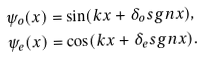Convert formula to latex. <formula><loc_0><loc_0><loc_500><loc_500>\psi _ { o } ( x ) & = \sin ( k x + \delta _ { o } s g n x ) , \\ \psi _ { e } ( x ) & = \cos ( k x + \delta _ { e } s g n x ) .</formula> 